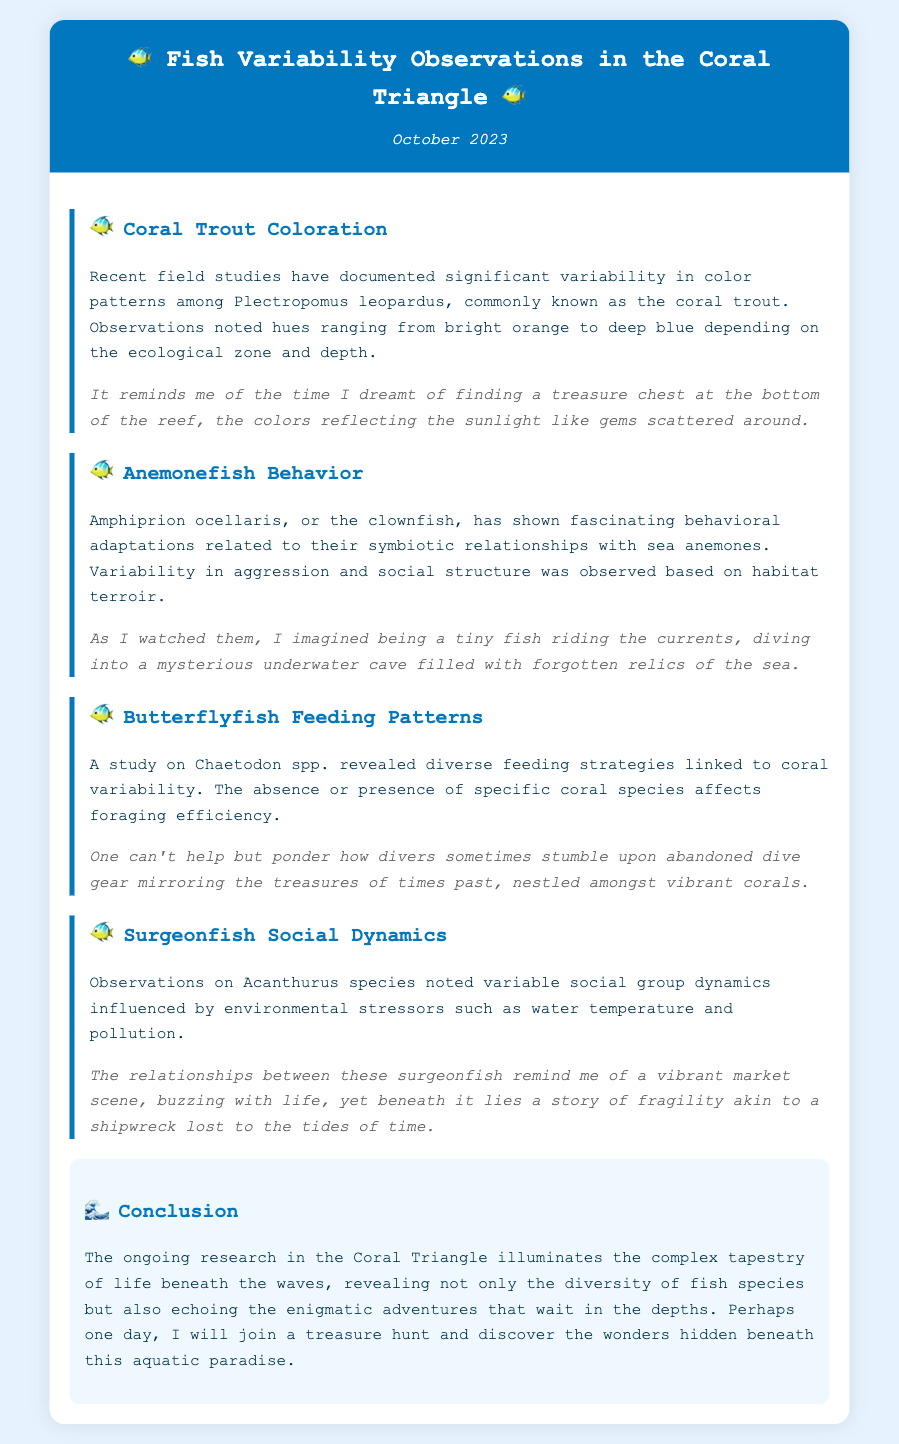What species is referred to as the coral trout? The document names Plectropomus leopardus as the coral trout.
Answer: Plectropomus leopardus What hues were observed in coral trout? The hues observed ranged from bright orange to deep blue.
Answer: Bright orange to deep blue What species is commonly known as the clownfish? The memo identifies Amphiprion ocellaris as the clownfish.
Answer: Amphiprion ocellaris What is linked to the feeding strategies of butterflyfish? The feeding strategies are linked to coral variability.
Answer: Coral variability Which fish species showed variability in social group dynamics? Acanthurus species noted variable social group dynamics.
Answer: Acanthurus species What environmental factors influence surgeonfish dynamics? The dynamics are influenced by environmental stressors such as water temperature and pollution.
Answer: Water temperature and pollution What color was used in the header of the memo? The header of the memo uses the color white for the text on a blue background.
Answer: White How many observations are detailed in the memo? There are four observations detailed in the memo.
Answer: Four What thematic element does the memo include in its conclusion? The conclusion includes the theme of underwater adventures.
Answer: Underwater adventures 